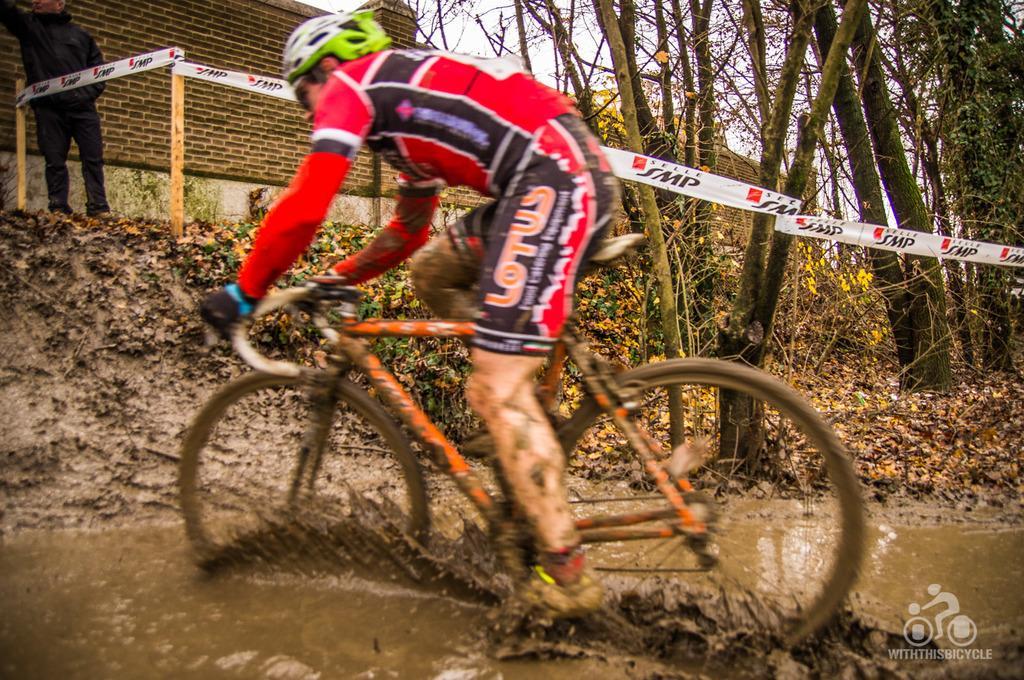Can you describe this image briefly? In this picture there is a boy who is cycling on the water in the image and there are trees and a house in the background area of the image, there is a man in the top left side of the image. 